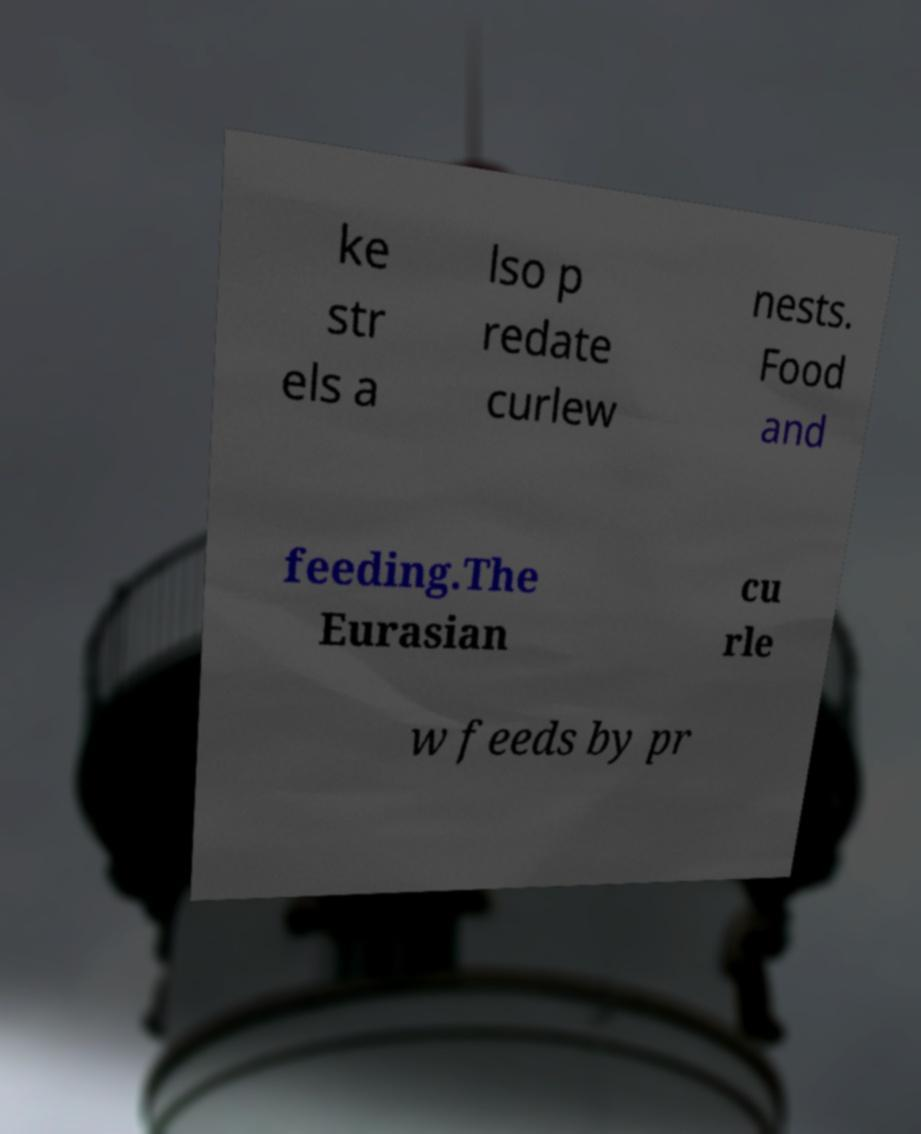Can you accurately transcribe the text from the provided image for me? ke str els a lso p redate curlew nests. Food and feeding.The Eurasian cu rle w feeds by pr 